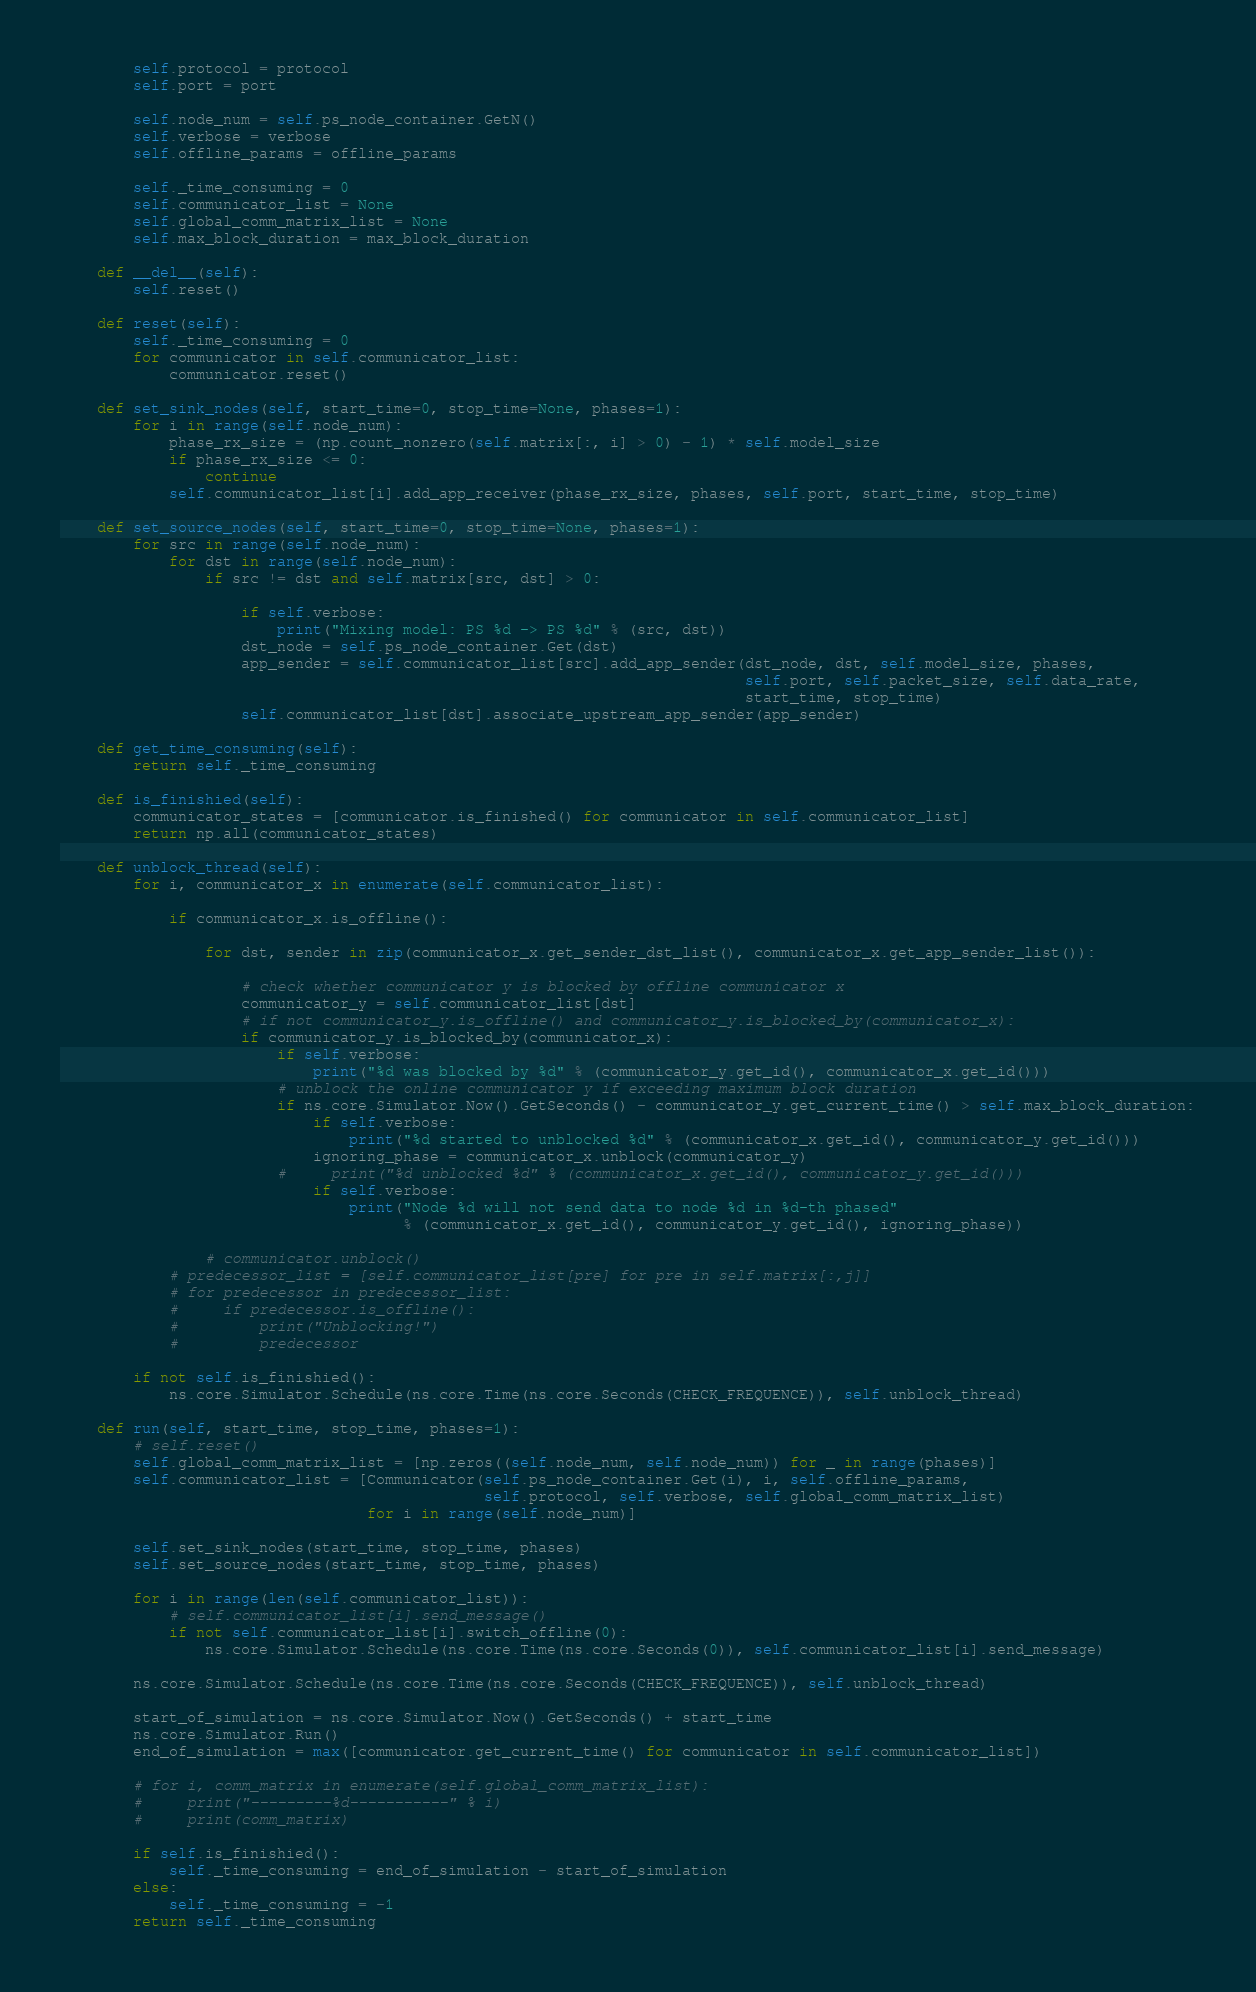Convert code to text. <code><loc_0><loc_0><loc_500><loc_500><_Python_>        self.protocol = protocol
        self.port = port

        self.node_num = self.ps_node_container.GetN()
        self.verbose = verbose
        self.offline_params = offline_params

        self._time_consuming = 0
        self.communicator_list = None
        self.global_comm_matrix_list = None
        self.max_block_duration = max_block_duration

    def __del__(self):
        self.reset()

    def reset(self):
        self._time_consuming = 0
        for communicator in self.communicator_list:
            communicator.reset()

    def set_sink_nodes(self, start_time=0, stop_time=None, phases=1):
        for i in range(self.node_num):
            phase_rx_size = (np.count_nonzero(self.matrix[:, i] > 0) - 1) * self.model_size
            if phase_rx_size <= 0:
                continue
            self.communicator_list[i].add_app_receiver(phase_rx_size, phases, self.port, start_time, stop_time)

    def set_source_nodes(self, start_time=0, stop_time=None, phases=1):
        for src in range(self.node_num):
            for dst in range(self.node_num):
                if src != dst and self.matrix[src, dst] > 0:

                    if self.verbose:
                        print("Mixing model: PS %d -> PS %d" % (src, dst))
                    dst_node = self.ps_node_container.Get(dst)
                    app_sender = self.communicator_list[src].add_app_sender(dst_node, dst, self.model_size, phases,
                                                                            self.port, self.packet_size, self.data_rate,
                                                                            start_time, stop_time)
                    self.communicator_list[dst].associate_upstream_app_sender(app_sender)

    def get_time_consuming(self):
        return self._time_consuming

    def is_finishied(self):
        communicator_states = [communicator.is_finished() for communicator in self.communicator_list]
        return np.all(communicator_states)

    def unblock_thread(self):
        for i, communicator_x in enumerate(self.communicator_list):

            if communicator_x.is_offline():

                for dst, sender in zip(communicator_x.get_sender_dst_list(), communicator_x.get_app_sender_list()):

                    # check whether communicator y is blocked by offline communicator x
                    communicator_y = self.communicator_list[dst]
                    # if not communicator_y.is_offline() and communicator_y.is_blocked_by(communicator_x):
                    if communicator_y.is_blocked_by(communicator_x):
                        if self.verbose:
                            print("%d was blocked by %d" % (communicator_y.get_id(), communicator_x.get_id()))
                        # unblock the online communicator y if exceeding maximum block duration
                        if ns.core.Simulator.Now().GetSeconds() - communicator_y.get_current_time() > self.max_block_duration:
                            if self.verbose:
                                print("%d started to unblocked %d" % (communicator_x.get_id(), communicator_y.get_id()))
                            ignoring_phase = communicator_x.unblock(communicator_y)
                        #     print("%d unblocked %d" % (communicator_x.get_id(), communicator_y.get_id()))
                            if self.verbose:
                                print("Node %d will not send data to node %d in %d-th phased"
                                      % (communicator_x.get_id(), communicator_y.get_id(), ignoring_phase))

                # communicator.unblock()
            # predecessor_list = [self.communicator_list[pre] for pre in self.matrix[:,j]]
            # for predecessor in predecessor_list:
            #     if predecessor.is_offline():
            #         print("Unblocking!")
            #         predecessor

        if not self.is_finishied():
            ns.core.Simulator.Schedule(ns.core.Time(ns.core.Seconds(CHECK_FREQUENCE)), self.unblock_thread)

    def run(self, start_time, stop_time, phases=1):
        # self.reset()
        self.global_comm_matrix_list = [np.zeros((self.node_num, self.node_num)) for _ in range(phases)]
        self.communicator_list = [Communicator(self.ps_node_container.Get(i), i, self.offline_params,
                                               self.protocol, self.verbose, self.global_comm_matrix_list)
                                  for i in range(self.node_num)]

        self.set_sink_nodes(start_time, stop_time, phases)
        self.set_source_nodes(start_time, stop_time, phases)

        for i in range(len(self.communicator_list)):
            # self.communicator_list[i].send_message()
            if not self.communicator_list[i].switch_offline(0):
                ns.core.Simulator.Schedule(ns.core.Time(ns.core.Seconds(0)), self.communicator_list[i].send_message)

        ns.core.Simulator.Schedule(ns.core.Time(ns.core.Seconds(CHECK_FREQUENCE)), self.unblock_thread)

        start_of_simulation = ns.core.Simulator.Now().GetSeconds() + start_time
        ns.core.Simulator.Run()
        end_of_simulation = max([communicator.get_current_time() for communicator in self.communicator_list])

        # for i, comm_matrix in enumerate(self.global_comm_matrix_list):
        #     print("---------%d-----------" % i)
        #     print(comm_matrix)

        if self.is_finishied():
            self._time_consuming = end_of_simulation - start_of_simulation
        else:
            self._time_consuming = -1
        return self._time_consuming
</code> 